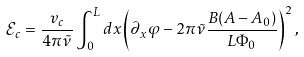<formula> <loc_0><loc_0><loc_500><loc_500>\mathcal { E } _ { c } = \frac { v _ { c } } { 4 \pi \tilde { \nu } } \int _ { 0 } ^ { L } d x \left ( \partial _ { x } \varphi - 2 \pi \tilde { \nu } \frac { B ( A - A _ { 0 } ) } { L \Phi _ { 0 } } \right ) ^ { 2 } ,</formula> 